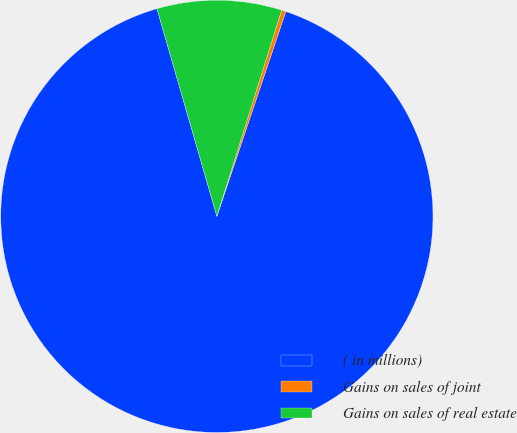<chart> <loc_0><loc_0><loc_500><loc_500><pie_chart><fcel>( in millions)<fcel>Gains on sales of joint<fcel>Gains on sales of real estate<nl><fcel>90.36%<fcel>0.32%<fcel>9.32%<nl></chart> 